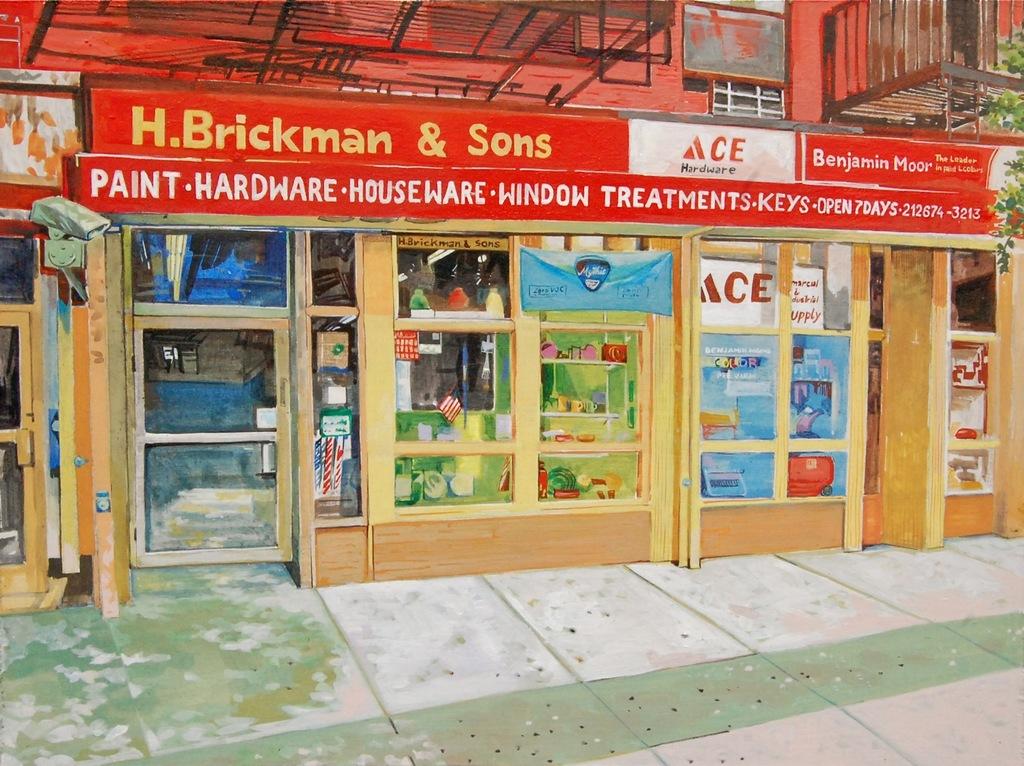What is the first word after "paint"?
Provide a succinct answer. Hardware. What is the name of this hardware store?
Your answer should be very brief. H. brickman & sons. 